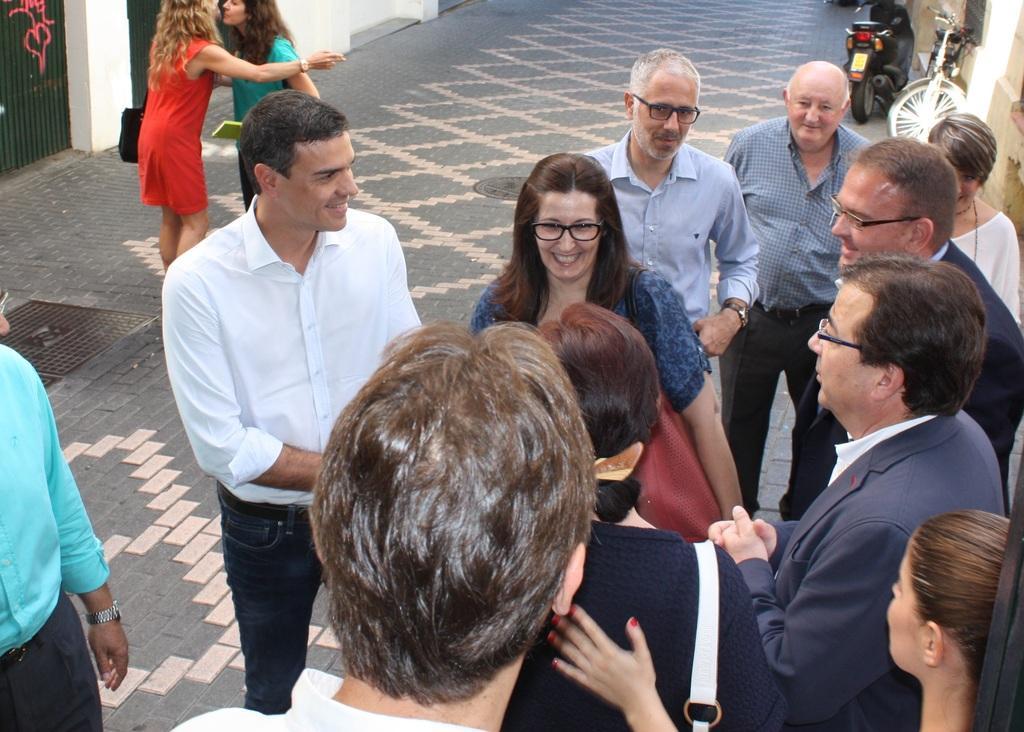Describe this image in one or two sentences. In this image I can see group of people standing. There are vehicles and there are walls. 